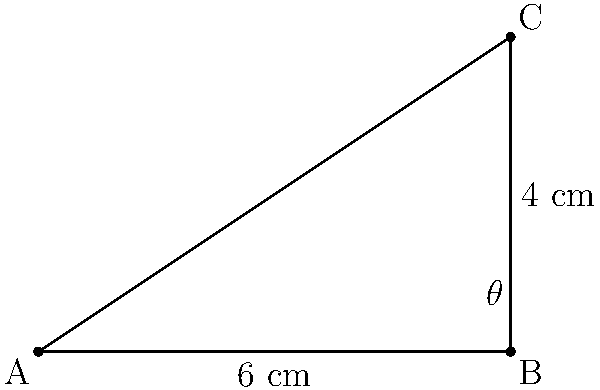As a novelist drawing inspiration from your editor-in-chief's meticulous organization, you notice a unique arrangement of books on their office shelf. One particular book catches your eye, and you decide to incorporate its positioning into your next story. The book's spine forms a right triangle with the shelf, where the adjacent side (along the shelf) measures 6 cm, and the opposite side (the height of the book) is 4 cm. What is the angle $\theta$ between the book's spine and the shelf? To solve this problem, we'll use the trigonometric function tangent, which is the ratio of the opposite side to the adjacent side in a right triangle.

Step 1: Identify the given information
- Adjacent side (along the shelf) = 6 cm
- Opposite side (height of the book) = 4 cm
- We need to find the angle $\theta$

Step 2: Recall the tangent function
$\tan \theta = \frac{\text{opposite}}{\text{adjacent}}$

Step 3: Substitute the known values
$\tan \theta = \frac{4}{6} = \frac{2}{3}$

Step 4: To find $\theta$, we need to use the inverse tangent function (arctan or $\tan^{-1}$)
$\theta = \tan^{-1}(\frac{2}{3})$

Step 5: Calculate the angle
$\theta \approx 33.69^\circ$

Step 6: Round to the nearest degree
$\theta \approx 34^\circ$

Thus, the angle between the book's spine and the shelf is approximately 34 degrees.
Answer: $34^\circ$ 